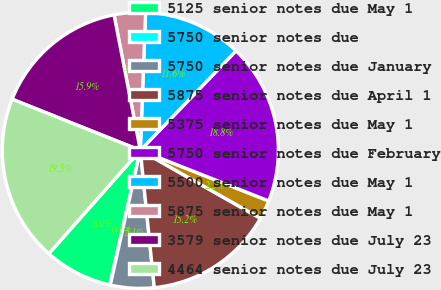<chart> <loc_0><loc_0><loc_500><loc_500><pie_chart><fcel>5125 senior notes due May 1<fcel>5750 senior notes due<fcel>5750 senior notes due January<fcel>5875 senior notes due April 1<fcel>5375 senior notes due May 1<fcel>5750 senior notes due February<fcel>5500 senior notes due May 1<fcel>5875 senior notes due May 1<fcel>3579 senior notes due July 23<fcel>4464 senior notes due July 23<nl><fcel>7.98%<fcel>0.06%<fcel>5.1%<fcel>15.19%<fcel>2.22%<fcel>18.79%<fcel>11.58%<fcel>3.66%<fcel>15.91%<fcel>19.51%<nl></chart> 